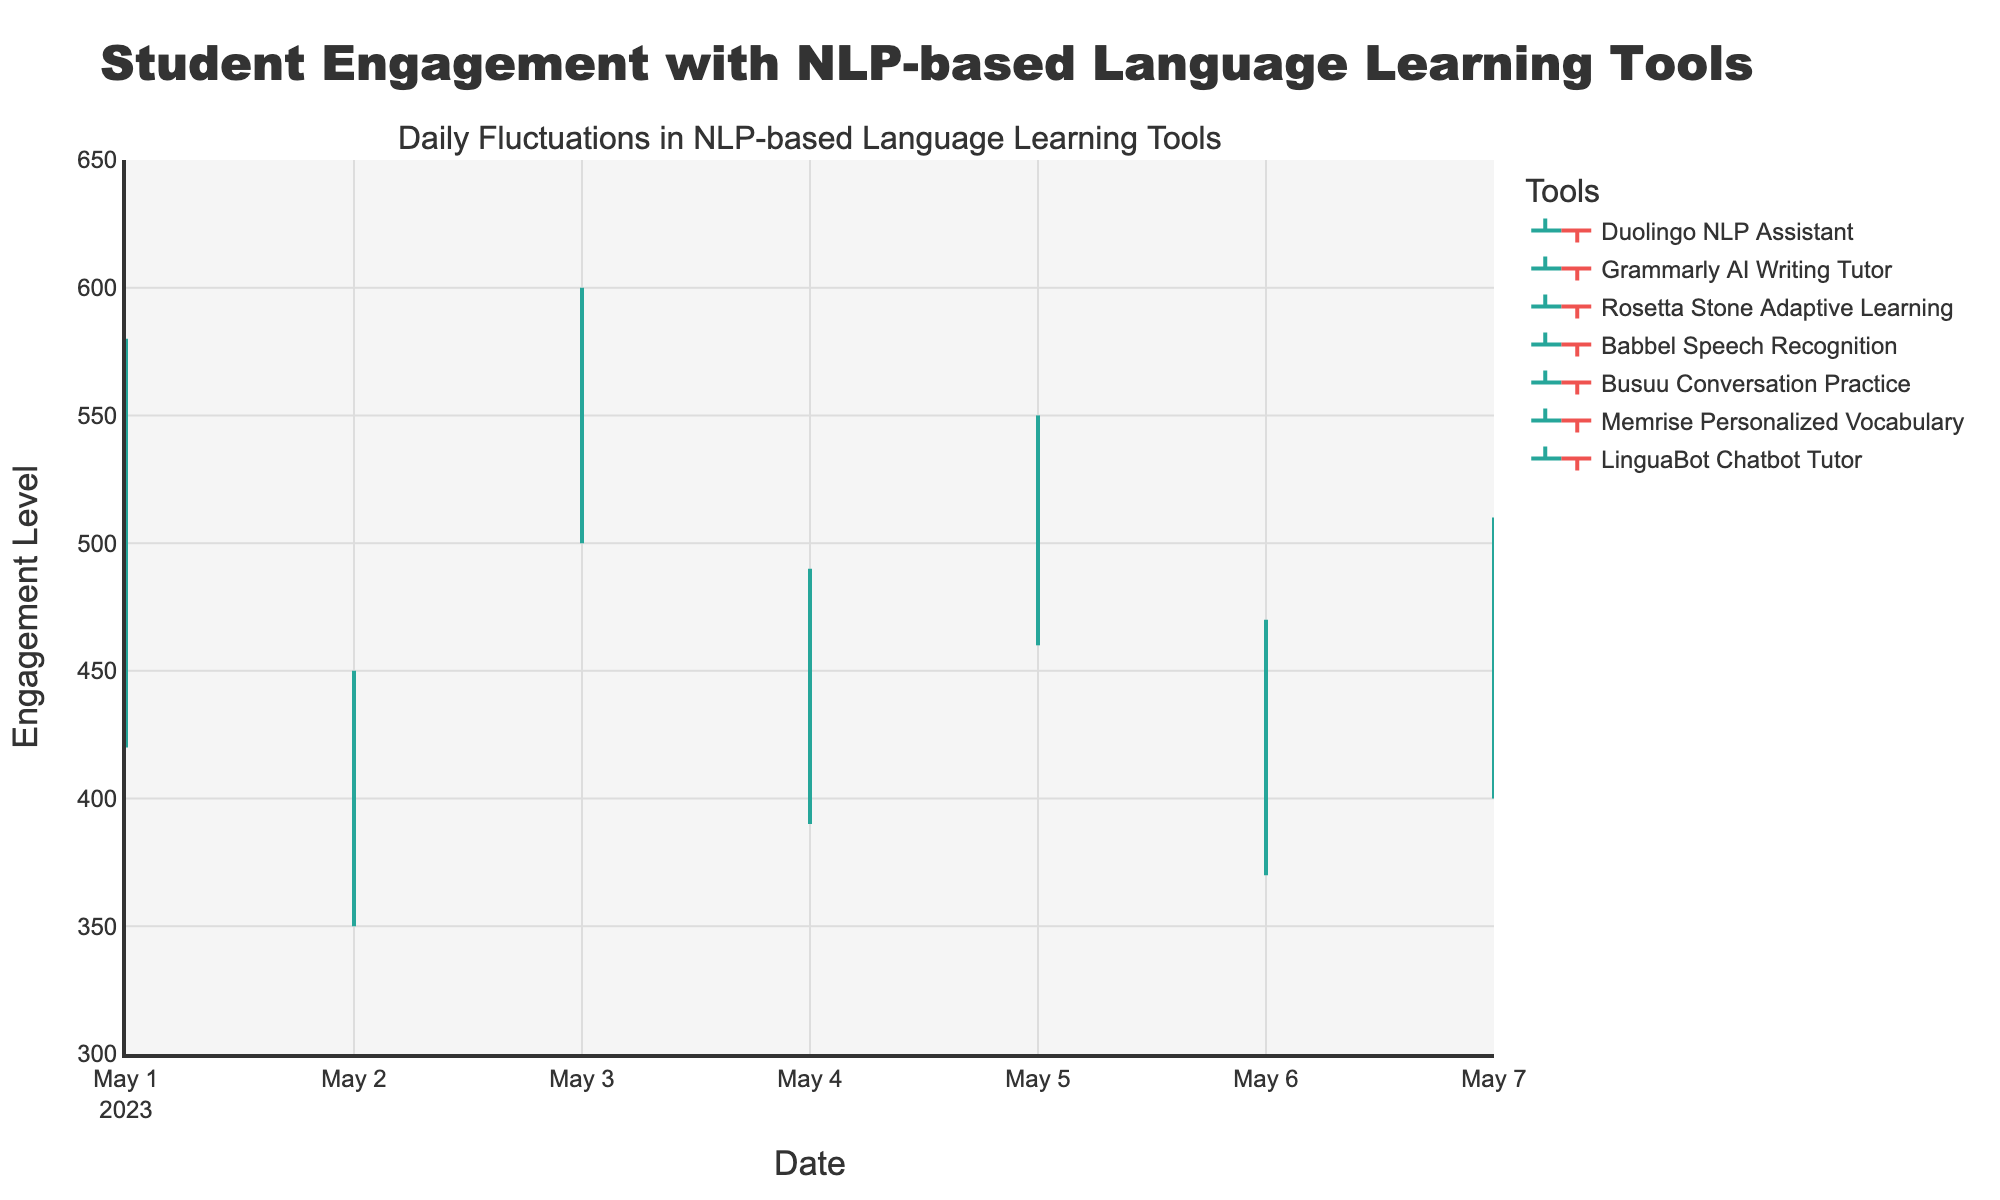What's the title of the chart? The title of the chart is found at the top of the figure. The title is provided to give an overview of what the chart represents.
Answer: Student Engagement with NLP-based Language Learning Tools How many NLP-based language learning tools are represented in the chart? Each unique color bar in the chart represents a different tool. By counting the legends, we can determine the number of tools.
Answer: 7 Which tool had the highest level of engagement on its highest day? The highest point on the vertical axis corresponds to the highest engagement level. By identifying the tallest bar, we can determine the tool associated with it.
Answer: Rosetta Stone Adaptive Learning What's the lowest engagement level recorded and for which tool? The lowest point on the vertical axis across all bars indicates the minimum engagement level. By following this point horizontally, we find the associated tool.
Answer: Grammarly AI Writing Tutor at 350 On which day did Busuu Conversation Practice show the most fluctuation in engagement levels? Fluctuation is determined by calculating the difference between the high and low values for each day. We then identify the day with the largest difference for Busuu Conversation Practice.
Answer: 2023-05-05 Compare the opening engagement levels of Duolingo NLP Assistant and LinguaBot Chatbot Tutor. Which one opened higher? The opening levels are shown at the start of each bar. By comparing the starting points of Duolingo NLP Assistant and LinguaBot Chatbot Tutor, we find which one is higher.
Answer: Duolingo NLP Assistant What was the average closing level for Babbel Speech Recognition over the given period? The closing levels for Babbel Speech Recognition across the days are averaged. This is done by summing the closing levels and dividing by the number of days.
Answer: 470 Which tool had a consistent increase in engagement levels from opening to closing across all days? A consistent increase means that for each day, the closing level is higher than the opening level. We review each tool to identify any that match this criterion.
Answer: LinguaBot Chatbot Tutor Compare the engagement fluctuations of Memrise Personalized Vocabulary and Babbel Speech Recognition. Which tool shows higher volatility? Volatility is measured by the difference between high and low values for each day. By comparing these differences for both tools, we determine which one shows higher fluctuations.
Answer: Babbel Speech Recognition What trend can you observe in the engagement levels for Rosetta Stone Adaptive Learning? Observing the high, low, opening, and closing values for Rosetta Stone Adaptive Learning over the days can help us identify patterns in the data, such as an increasing or decreasing trend over time.
Answer: Increasing trend 